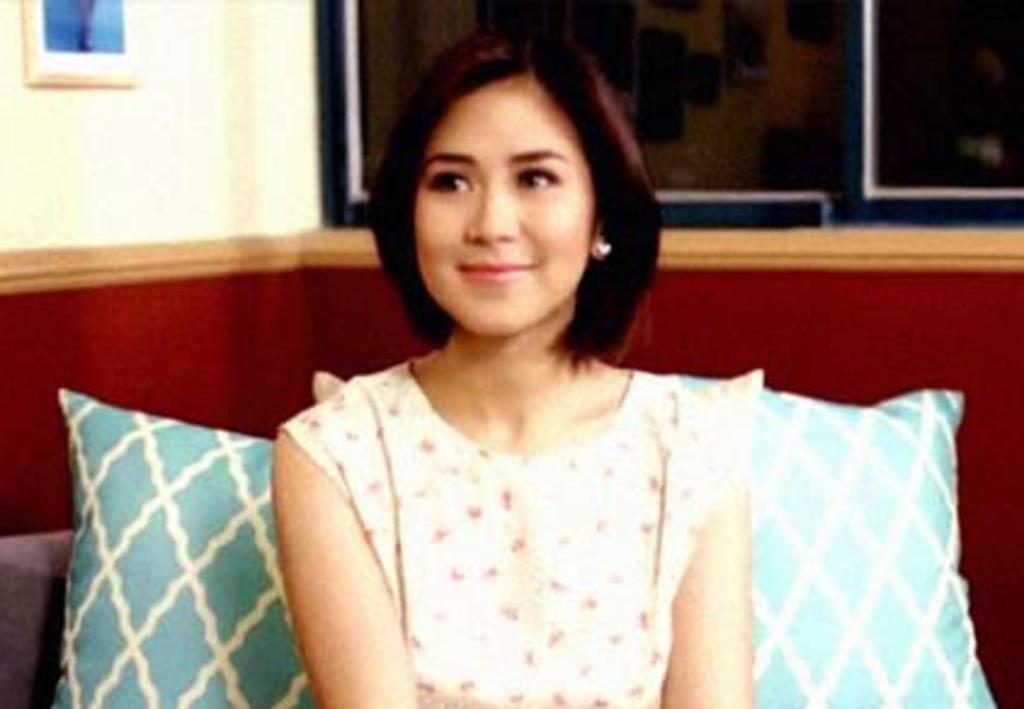In one or two sentences, can you explain what this image depicts? In this picture there is a woman who is wearing white dress. She is smiling. She is sitting on the couch. Here we can see some pillows. On the top there is a window. On the top left corner there is a photo frame on the wall. 